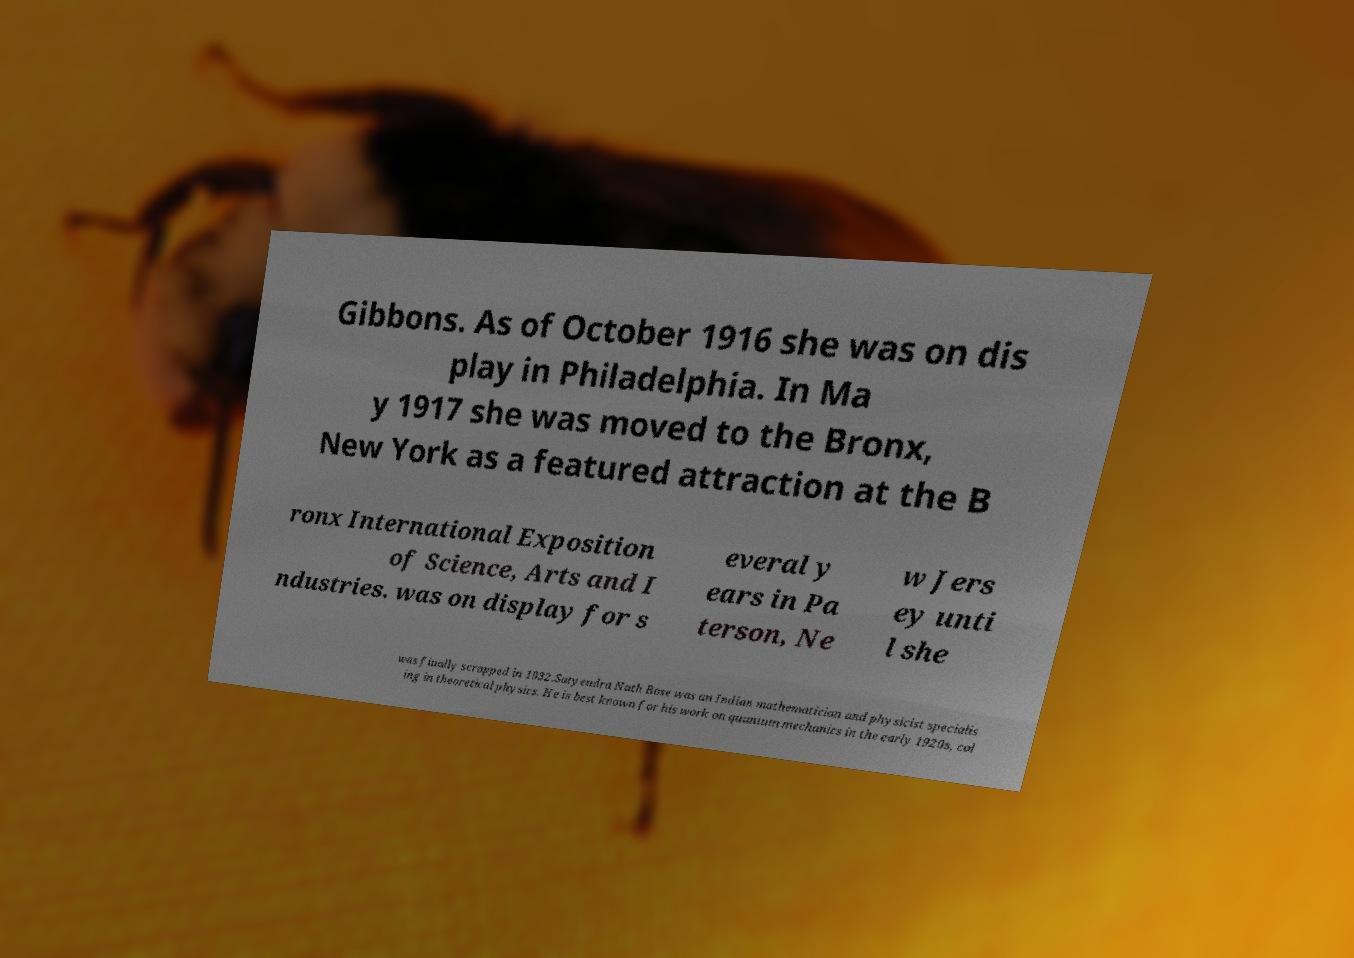What messages or text are displayed in this image? I need them in a readable, typed format. Gibbons. As of October 1916 she was on dis play in Philadelphia. In Ma y 1917 she was moved to the Bronx, New York as a featured attraction at the B ronx International Exposition of Science, Arts and I ndustries. was on display for s everal y ears in Pa terson, Ne w Jers ey unti l she was finally scrapped in 1932.Satyendra Nath Bose was an Indian mathematician and physicist specialis ing in theoretical physics. He is best known for his work on quantum mechanics in the early 1920s, col 